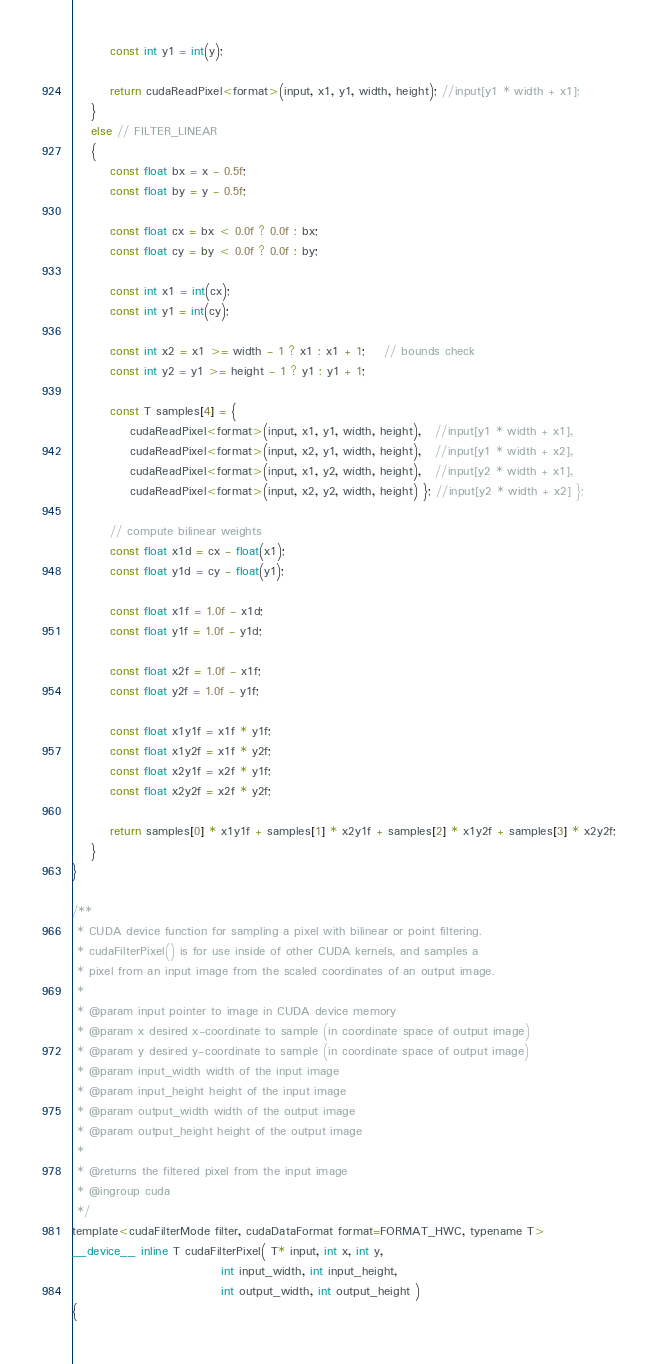Convert code to text. <code><loc_0><loc_0><loc_500><loc_500><_Cuda_>		const int y1 = int(y);

		return cudaReadPixel<format>(input, x1, y1, width, height); //input[y1 * width + x1];
	}
	else // FILTER_LINEAR
	{
		const float bx = x - 0.5f;
		const float by = y - 0.5f;

		const float cx = bx < 0.0f ? 0.0f : bx;
		const float cy = by < 0.0f ? 0.0f : by;

		const int x1 = int(cx);
		const int y1 = int(cy);
			
		const int x2 = x1 >= width - 1 ? x1 : x1 + 1;	// bounds check
		const int y2 = y1 >= height - 1 ? y1 : y1 + 1;
		
		const T samples[4] = {
			cudaReadPixel<format>(input, x1, y1, width, height),   //input[y1 * width + x1],
			cudaReadPixel<format>(input, x2, y1, width, height),   //input[y1 * width + x2],
			cudaReadPixel<format>(input, x1, y2, width, height),   //input[y2 * width + x1],
			cudaReadPixel<format>(input, x2, y2, width, height) }; //input[y2 * width + x2] };

		// compute bilinear weights
		const float x1d = cx - float(x1);
		const float y1d = cy - float(y1);

		const float x1f = 1.0f - x1d;
		const float y1f = 1.0f - y1d;

		const float x2f = 1.0f - x1f;
		const float y2f = 1.0f - y1f;

		const float x1y1f = x1f * y1f;
		const float x1y2f = x1f * y2f;
		const float x2y1f = x2f * y1f;
		const float x2y2f = x2f * y2f;

		return samples[0] * x1y1f + samples[1] * x2y1f + samples[2] * x1y2f + samples[3] * x2y2f;
	}
}

/**
 * CUDA device function for sampling a pixel with bilinear or point filtering.
 * cudaFilterPixel() is for use inside of other CUDA kernels, and samples a
 * pixel from an input image from the scaled coordinates of an output image.
 *
 * @param input pointer to image in CUDA device memory
 * @param x desired x-coordinate to sample (in coordinate space of output image)
 * @param y desired y-coordinate to sample (in coordinate space of output image)
 * @param input_width width of the input image
 * @param input_height height of the input image
 * @param output_width width of the output image
 * @param output_height height of the output image
 *
 * @returns the filtered pixel from the input image
 * @ingroup cuda
 */ 
template<cudaFilterMode filter, cudaDataFormat format=FORMAT_HWC, typename T>
__device__ inline T cudaFilterPixel( T* input, int x, int y,
						       int input_width, int input_height,
						       int output_width, int output_height )
{</code> 